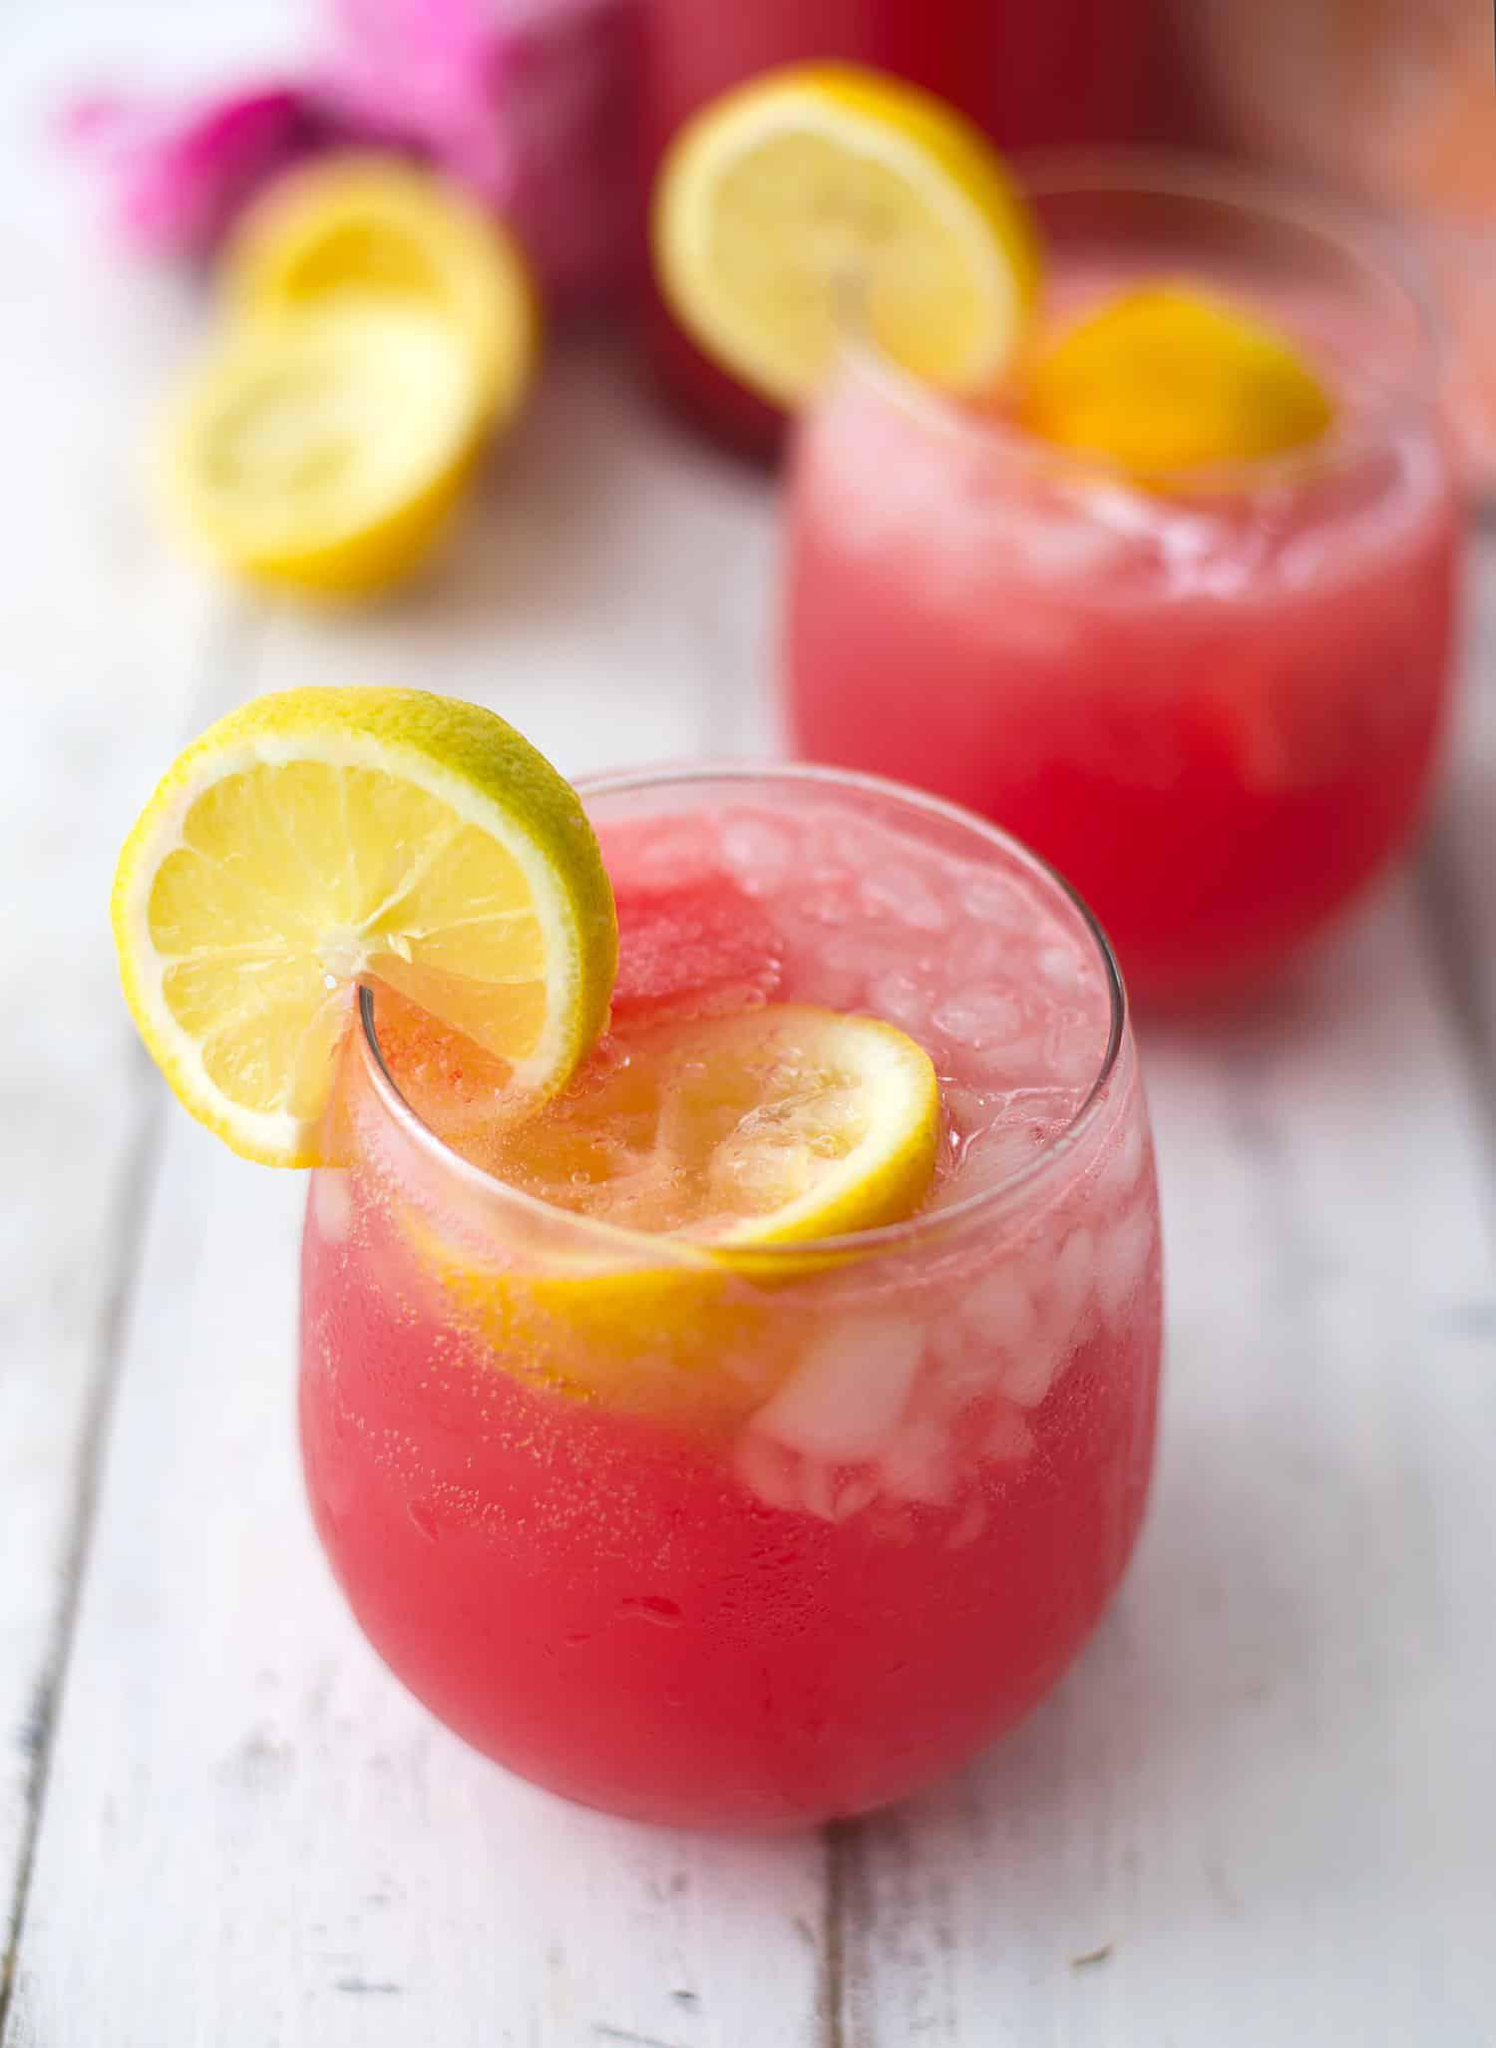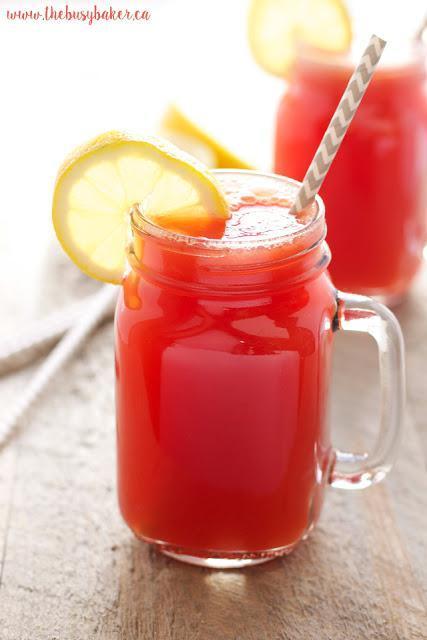The first image is the image on the left, the second image is the image on the right. Examine the images to the left and right. Is the description "Both images show a red drink in a clear glass with a lemon slice on the edge of the glass" accurate? Answer yes or no. Yes. The first image is the image on the left, the second image is the image on the right. Evaluate the accuracy of this statement regarding the images: "At least some of the beverages are served in jars and have straws inserted.". Is it true? Answer yes or no. Yes. 